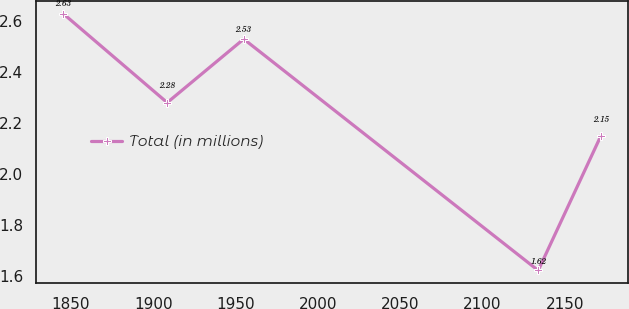Convert chart. <chart><loc_0><loc_0><loc_500><loc_500><line_chart><ecel><fcel>Total (in millions)<nl><fcel>1845.39<fcel>2.63<nl><fcel>1908.54<fcel>2.28<nl><fcel>1954.99<fcel>2.53<nl><fcel>2133.74<fcel>1.62<nl><fcel>2171.82<fcel>2.15<nl></chart> 